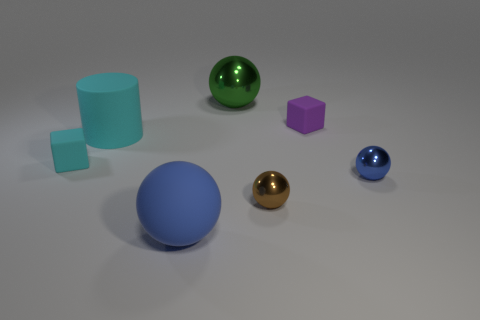Subtract all purple cubes. How many blue spheres are left? 2 Subtract all green balls. How many balls are left? 3 Subtract all brown balls. How many balls are left? 3 Add 3 big blue rubber cubes. How many objects exist? 10 Subtract all cylinders. How many objects are left? 6 Subtract all brown balls. Subtract all yellow blocks. How many balls are left? 3 Subtract all gray balls. Subtract all big cyan matte objects. How many objects are left? 6 Add 1 tiny brown objects. How many tiny brown objects are left? 2 Add 2 small purple matte cubes. How many small purple matte cubes exist? 3 Subtract 2 blue spheres. How many objects are left? 5 